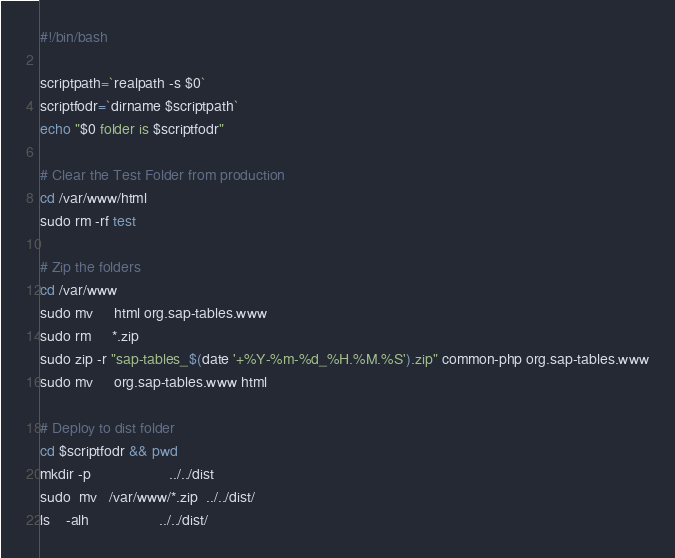Convert code to text. <code><loc_0><loc_0><loc_500><loc_500><_Bash_>#!/bin/bash

scriptpath=`realpath -s $0`
scriptfodr=`dirname $scriptpath`
echo "$0 folder is $scriptfodr"

# Clear the Test Folder from production
cd /var/www/html
sudo rm -rf test

# Zip the folders
cd /var/www
sudo mv     html org.sap-tables.www
sudo rm     *.zip
sudo zip -r "sap-tables_$(date '+%Y-%m-%d_%H.%M.%S').zip" common-php org.sap-tables.www
sudo mv     org.sap-tables.www html

# Deploy to dist folder
cd $scriptfodr && pwd
mkdir -p                   ../../dist
sudo  mv   /var/www/*.zip  ../../dist/
ls    -alh                 ../../dist/
</code> 